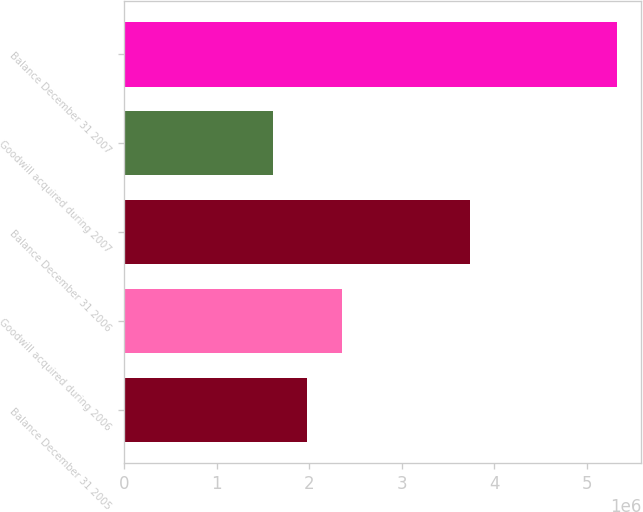Convert chart. <chart><loc_0><loc_0><loc_500><loc_500><bar_chart><fcel>Balance December 31 2005<fcel>Goodwill acquired during 2006<fcel>Balance December 31 2006<fcel>Goodwill acquired during 2007<fcel>Balance December 31 2007<nl><fcel>1.97841e+06<fcel>2.35046e+06<fcel>3.73754e+06<fcel>1.60636e+06<fcel>5.32683e+06<nl></chart> 